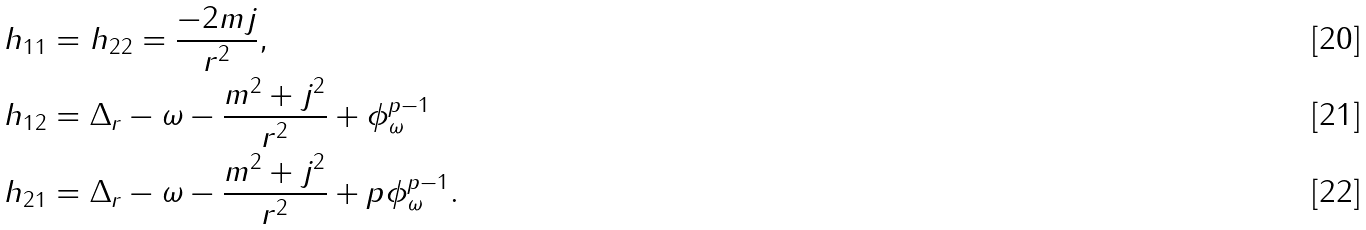<formula> <loc_0><loc_0><loc_500><loc_500>h _ { 1 1 } & = h _ { 2 2 } = \frac { - 2 m j } { r ^ { 2 } } , \\ h _ { 1 2 } & = \Delta _ { r } - \omega - \frac { m ^ { 2 } + j ^ { 2 } } { r ^ { 2 } } + \phi _ { \omega } ^ { p - 1 } \\ h _ { 2 1 } & = \Delta _ { r } - \omega - \frac { m ^ { 2 } + j ^ { 2 } } { r ^ { 2 } } + p \phi _ { \omega } ^ { p - 1 } .</formula> 